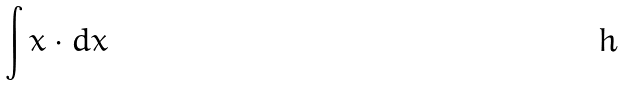Convert formula to latex. <formula><loc_0><loc_0><loc_500><loc_500>\int x \cdot d x</formula> 